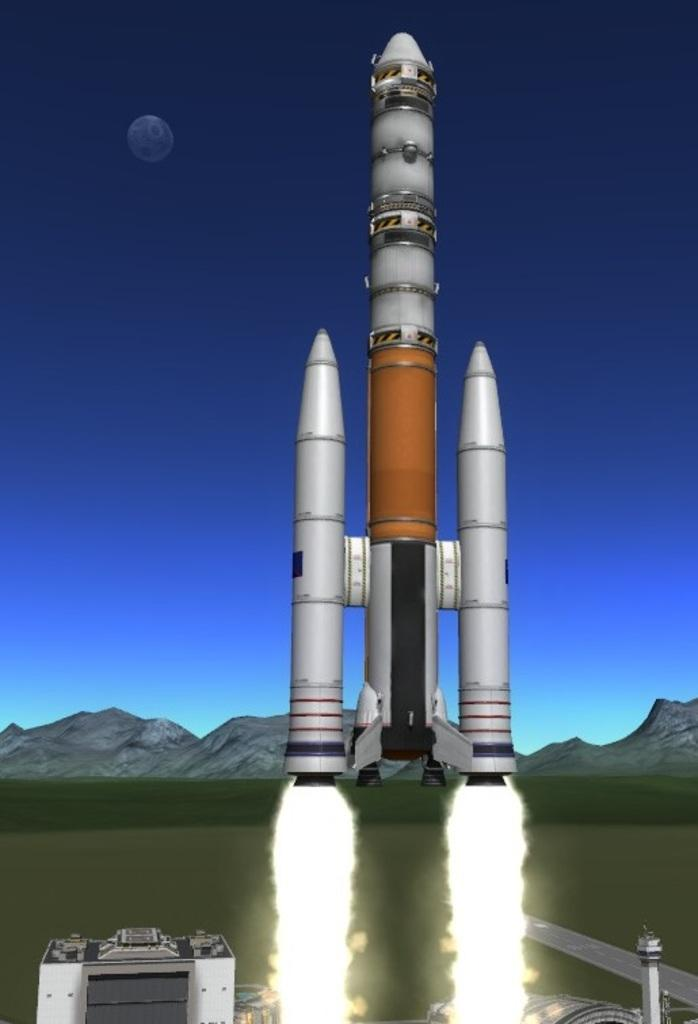What is the main subject of the picture? The main subject of the picture is a rocket. What is happening to the rocket in the image? There is fire beneath the rocket, suggesting that it is launching or has just launched. What can be seen in the background of the picture? There are mountains in the backdrop of the picture. What is the condition of the sky in the image? The sky is clear in the picture. What celestial body is visible in the sky? The moon is visible in the sky. What type of yarn is being used to hold the rocket in place in the image? There is no yarn present in the image, and the rocket is not being held in place. Can you see a chain attached to the rocket in the image? No, there is no chain attached to the rocket in the image. 